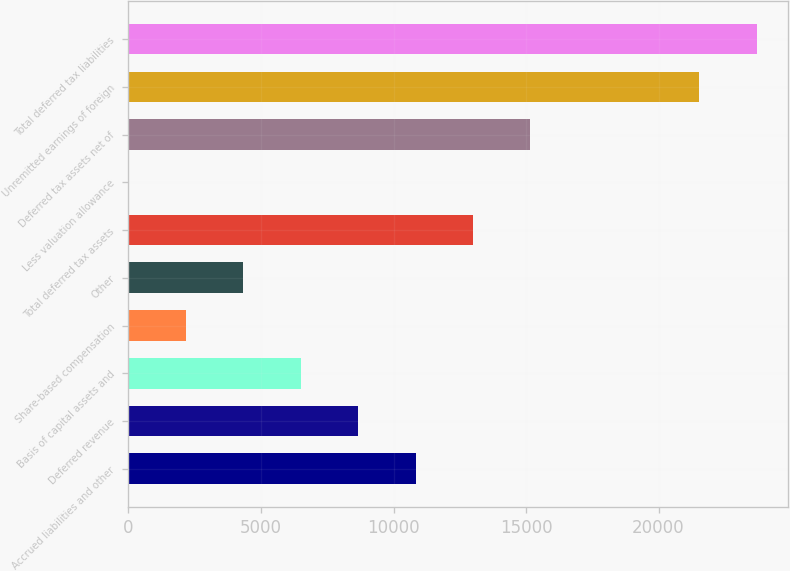Convert chart. <chart><loc_0><loc_0><loc_500><loc_500><bar_chart><fcel>Accrued liabilities and other<fcel>Deferred revenue<fcel>Basis of capital assets and<fcel>Share-based compensation<fcel>Other<fcel>Total deferred tax assets<fcel>Less valuation allowance<fcel>Deferred tax assets net of<fcel>Unremitted earnings of foreign<fcel>Total deferred tax liabilities<nl><fcel>10834.4<fcel>8668.45<fcel>6502.52<fcel>2170.66<fcel>4336.59<fcel>13000.3<fcel>4.73<fcel>15166.2<fcel>21544<fcel>23709.9<nl></chart> 